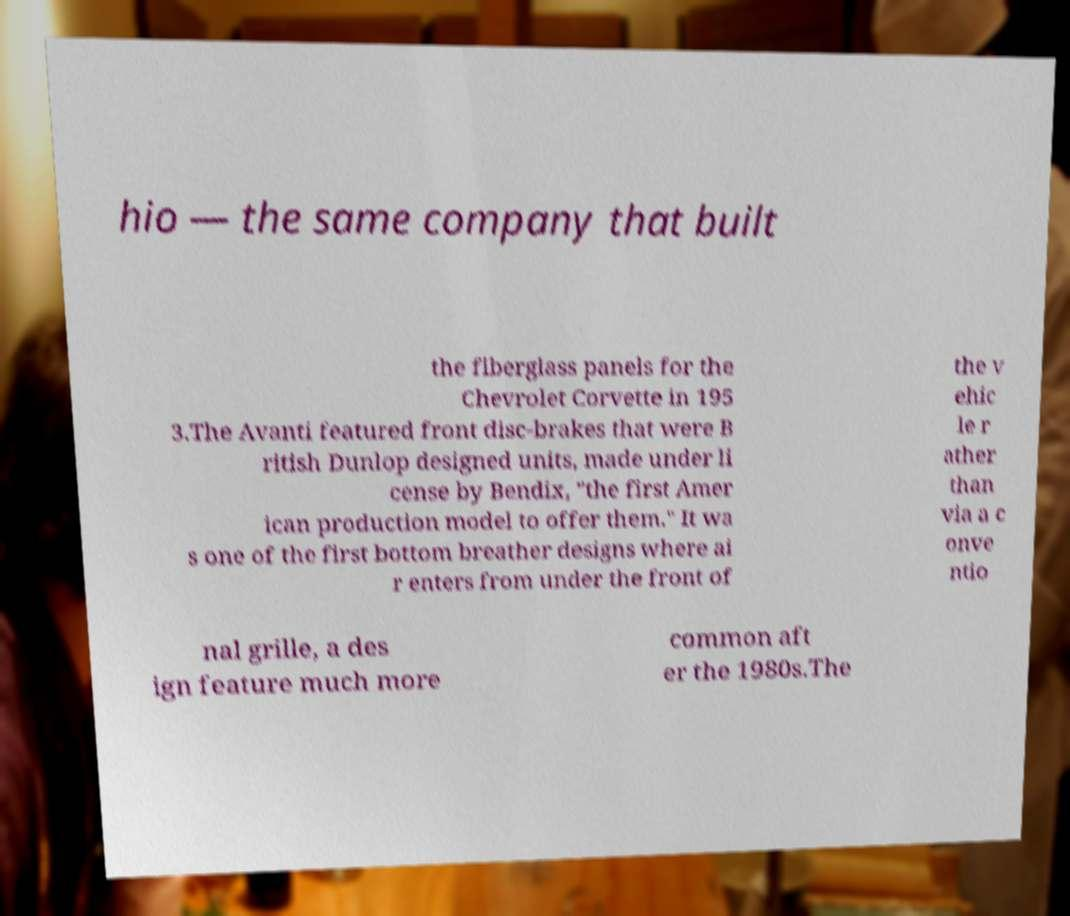Can you read and provide the text displayed in the image?This photo seems to have some interesting text. Can you extract and type it out for me? hio — the same company that built the fiberglass panels for the Chevrolet Corvette in 195 3.The Avanti featured front disc-brakes that were B ritish Dunlop designed units, made under li cense by Bendix, "the first Amer ican production model to offer them." It wa s one of the first bottom breather designs where ai r enters from under the front of the v ehic le r ather than via a c onve ntio nal grille, a des ign feature much more common aft er the 1980s.The 